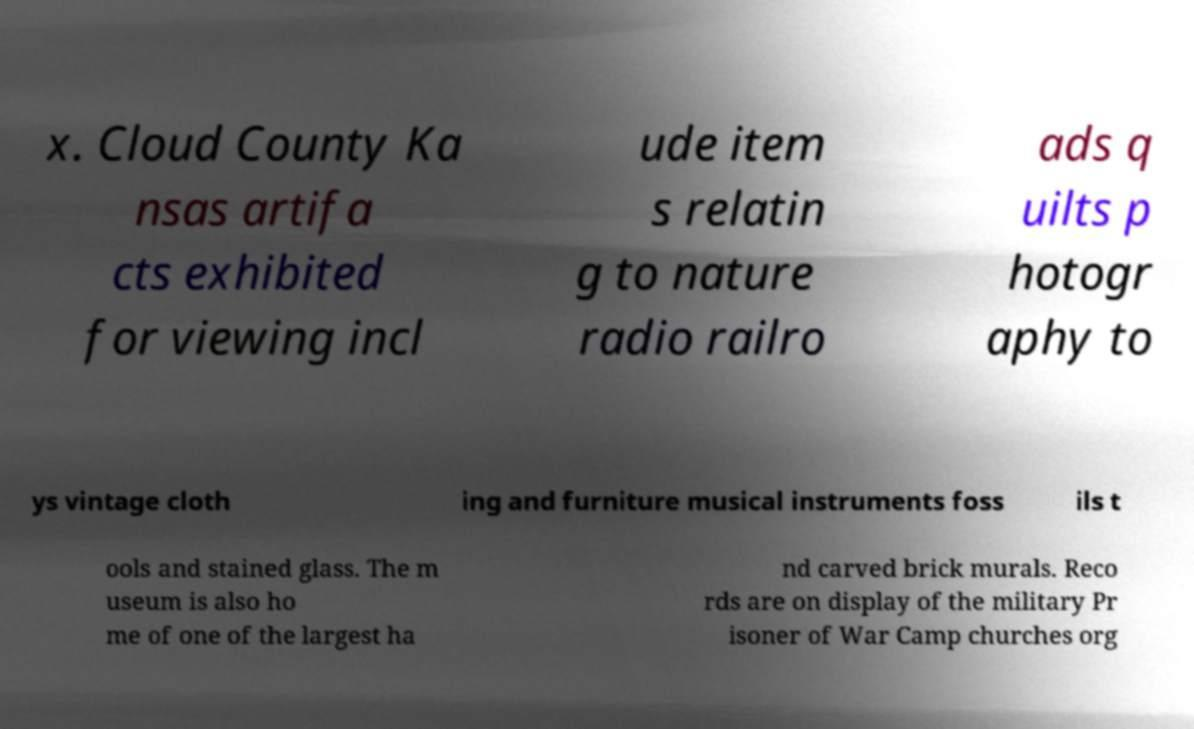Please identify and transcribe the text found in this image. x. Cloud County Ka nsas artifa cts exhibited for viewing incl ude item s relatin g to nature radio railro ads q uilts p hotogr aphy to ys vintage cloth ing and furniture musical instruments foss ils t ools and stained glass. The m useum is also ho me of one of the largest ha nd carved brick murals. Reco rds are on display of the military Pr isoner of War Camp churches org 